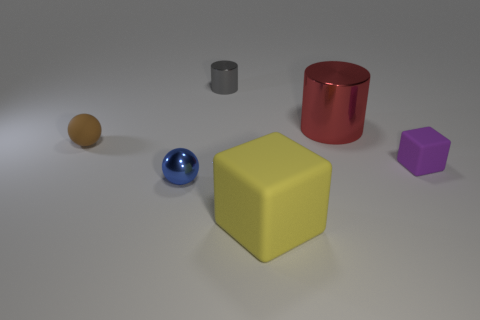Add 1 tiny matte cubes. How many objects exist? 7 Subtract all cylinders. How many objects are left? 4 Add 6 small gray cylinders. How many small gray cylinders are left? 7 Add 6 tiny metal objects. How many tiny metal objects exist? 8 Subtract 1 gray cylinders. How many objects are left? 5 Subtract all yellow objects. Subtract all blue metal balls. How many objects are left? 4 